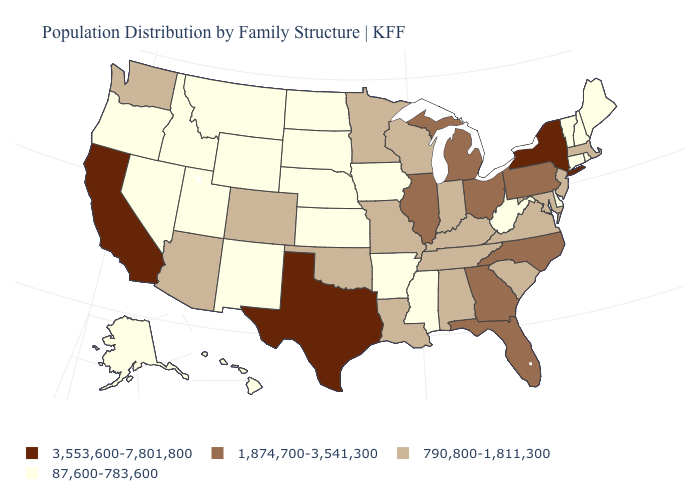Does South Carolina have a lower value than Kansas?
Concise answer only. No. Name the states that have a value in the range 3,553,600-7,801,800?
Answer briefly. California, New York, Texas. What is the value of California?
Concise answer only. 3,553,600-7,801,800. What is the value of West Virginia?
Quick response, please. 87,600-783,600. What is the value of Wyoming?
Write a very short answer. 87,600-783,600. What is the lowest value in the USA?
Give a very brief answer. 87,600-783,600. What is the value of Michigan?
Be succinct. 1,874,700-3,541,300. Does Michigan have a lower value than New Mexico?
Concise answer only. No. What is the value of Colorado?
Keep it brief. 790,800-1,811,300. Name the states that have a value in the range 87,600-783,600?
Keep it brief. Alaska, Arkansas, Connecticut, Delaware, Hawaii, Idaho, Iowa, Kansas, Maine, Mississippi, Montana, Nebraska, Nevada, New Hampshire, New Mexico, North Dakota, Oregon, Rhode Island, South Dakota, Utah, Vermont, West Virginia, Wyoming. How many symbols are there in the legend?
Give a very brief answer. 4. What is the value of Missouri?
Be succinct. 790,800-1,811,300. What is the value of Colorado?
Be succinct. 790,800-1,811,300. What is the lowest value in the USA?
Give a very brief answer. 87,600-783,600. What is the lowest value in states that border Texas?
Be succinct. 87,600-783,600. 